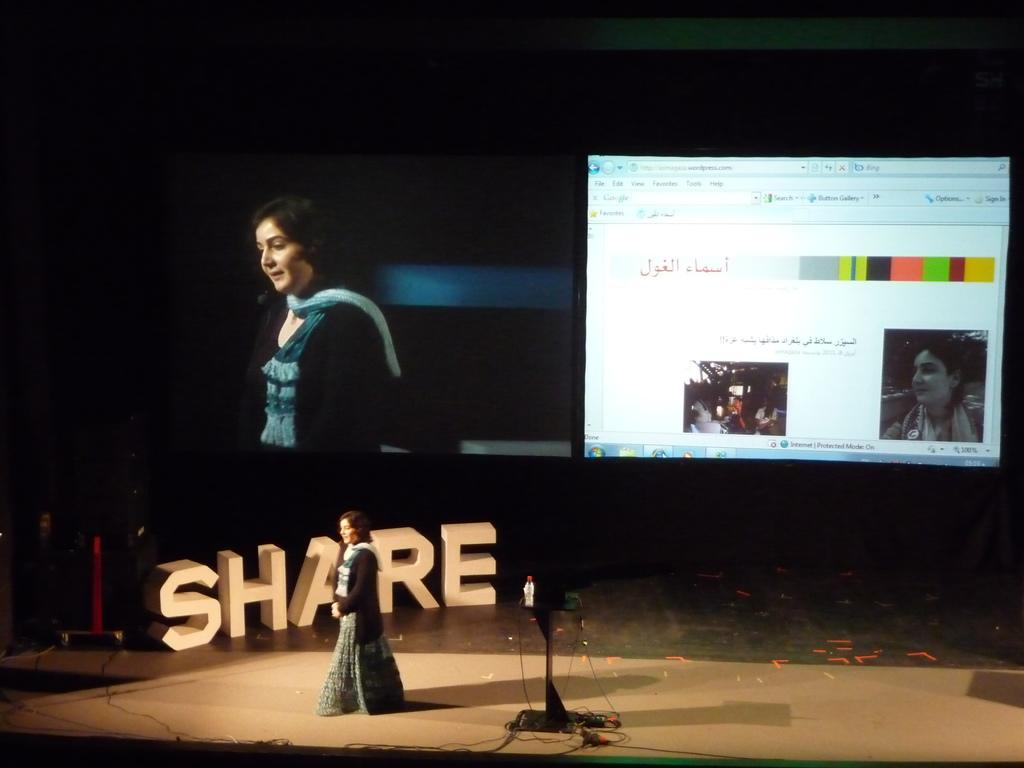What is the main subject of the image? There is a lady standing on a stage in the image. What can be seen in the background of the image? There is text in the background of the image. Can you describe another image within the collage? There is another image within the collage that contains a lady and a monitor. How does the lady's stomach feel during the performance in the image? There is no information about the lady's stomach or her feelings in the image. 